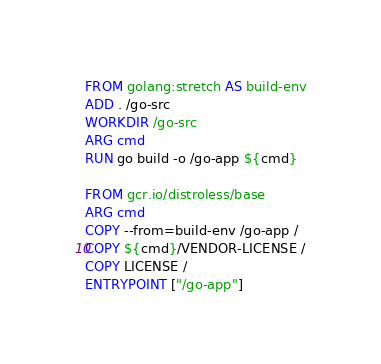Convert code to text. <code><loc_0><loc_0><loc_500><loc_500><_Dockerfile_>FROM golang:stretch AS build-env
ADD . /go-src
WORKDIR /go-src
ARG cmd
RUN go build -o /go-app ${cmd}

FROM gcr.io/distroless/base
ARG cmd
COPY --from=build-env /go-app /
COPY ${cmd}/VENDOR-LICENSE /
COPY LICENSE /
ENTRYPOINT ["/go-app"]
</code> 